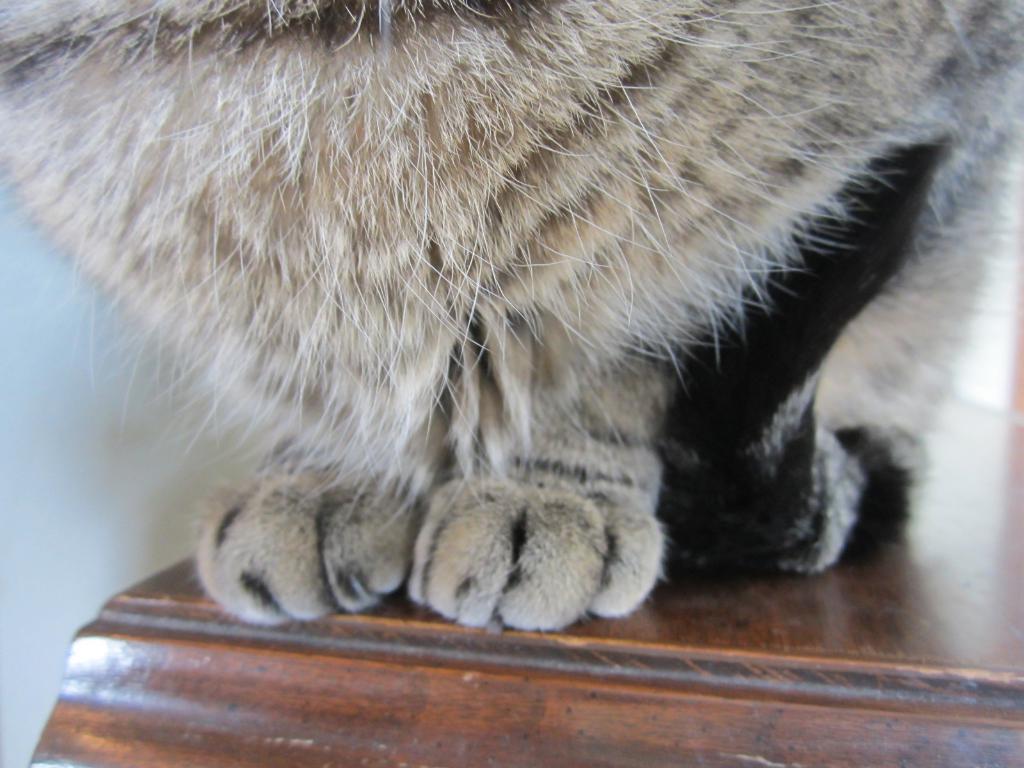How would you summarize this image in a sentence or two? In this image we can see an animal on the table and also we can see the wall. 